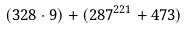Convert formula to latex. <formula><loc_0><loc_0><loc_500><loc_500>( 3 2 8 \cdot 9 ) + ( 2 8 7 ^ { 2 2 1 } + 4 7 3 )</formula> 